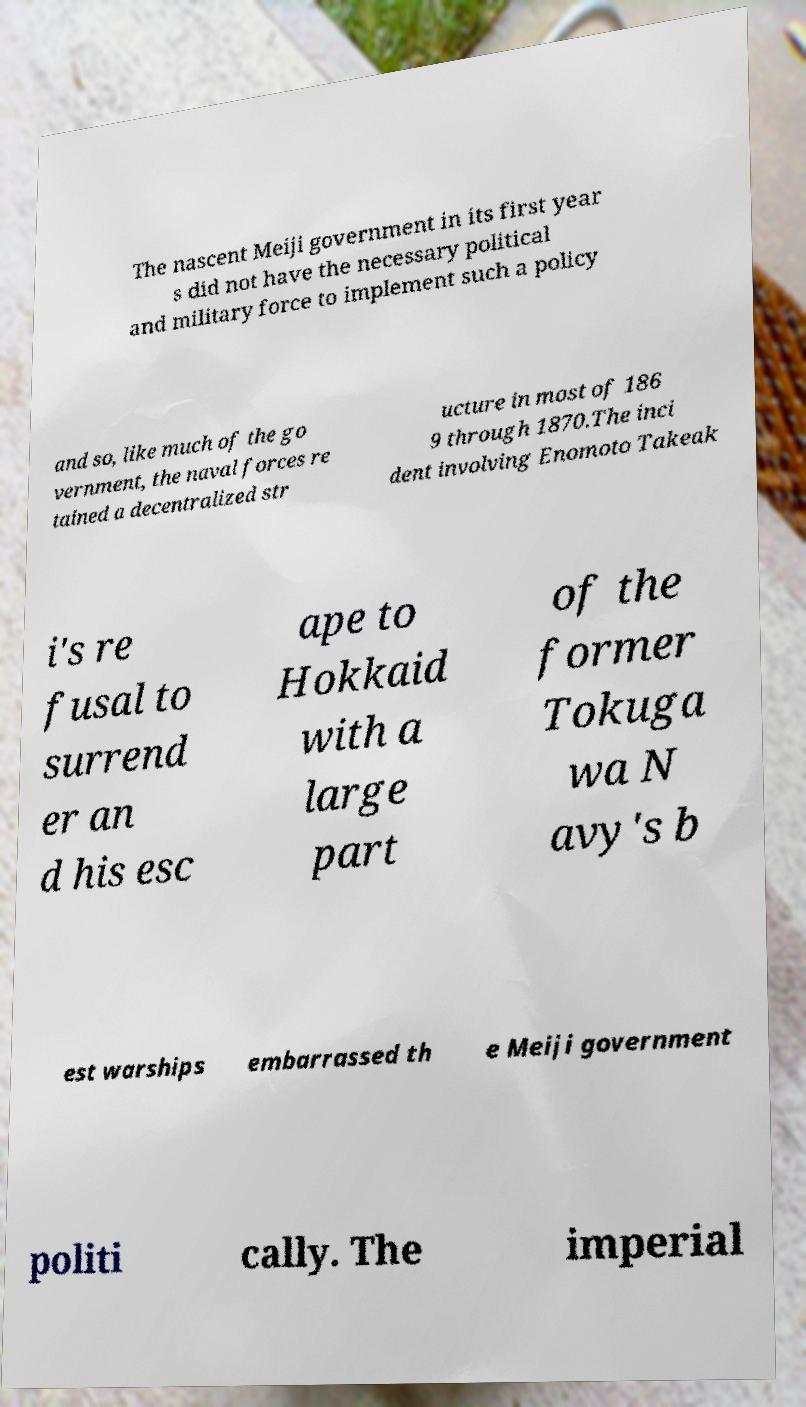There's text embedded in this image that I need extracted. Can you transcribe it verbatim? The nascent Meiji government in its first year s did not have the necessary political and military force to implement such a policy and so, like much of the go vernment, the naval forces re tained a decentralized str ucture in most of 186 9 through 1870.The inci dent involving Enomoto Takeak i's re fusal to surrend er an d his esc ape to Hokkaid with a large part of the former Tokuga wa N avy's b est warships embarrassed th e Meiji government politi cally. The imperial 